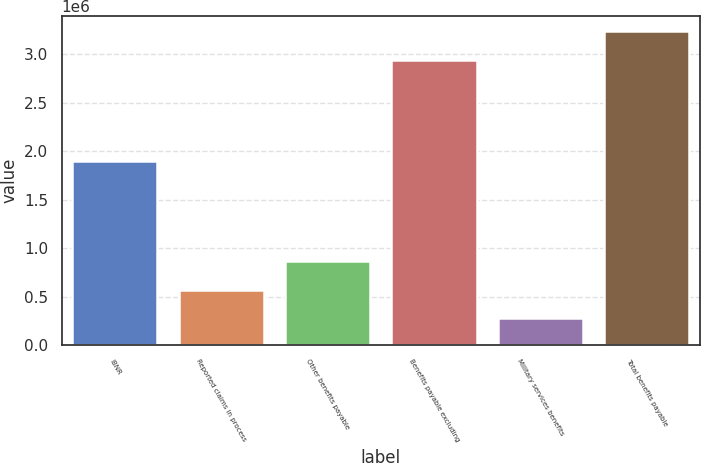Convert chart to OTSL. <chart><loc_0><loc_0><loc_500><loc_500><bar_chart><fcel>IBNR<fcel>Reported claims in process<fcel>Other benefits payable<fcel>Benefits payable excluding<fcel>Military services benefits<fcel>Total benefits payable<nl><fcel>1.9027e+06<fcel>573533<fcel>867871<fcel>2.94338e+06<fcel>279195<fcel>3.23772e+06<nl></chart> 